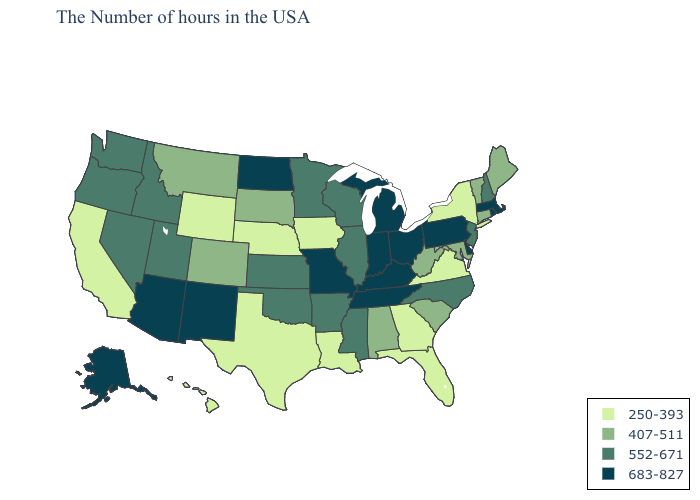Does the map have missing data?
Concise answer only. No. Does Pennsylvania have the highest value in the USA?
Short answer required. Yes. Does New Mexico have the lowest value in the West?
Be succinct. No. Name the states that have a value in the range 552-671?
Concise answer only. New Hampshire, New Jersey, North Carolina, Wisconsin, Illinois, Mississippi, Arkansas, Minnesota, Kansas, Oklahoma, Utah, Idaho, Nevada, Washington, Oregon. Among the states that border Colorado , does Arizona have the lowest value?
Give a very brief answer. No. What is the lowest value in states that border California?
Keep it brief. 552-671. What is the lowest value in states that border Wyoming?
Be succinct. 250-393. How many symbols are there in the legend?
Give a very brief answer. 4. Does Alabama have the highest value in the USA?
Answer briefly. No. What is the value of Arkansas?
Answer briefly. 552-671. What is the highest value in the USA?
Give a very brief answer. 683-827. Name the states that have a value in the range 683-827?
Write a very short answer. Massachusetts, Rhode Island, Delaware, Pennsylvania, Ohio, Michigan, Kentucky, Indiana, Tennessee, Missouri, North Dakota, New Mexico, Arizona, Alaska. What is the lowest value in the USA?
Give a very brief answer. 250-393. What is the value of Nevada?
Be succinct. 552-671. What is the value of Florida?
Be succinct. 250-393. 